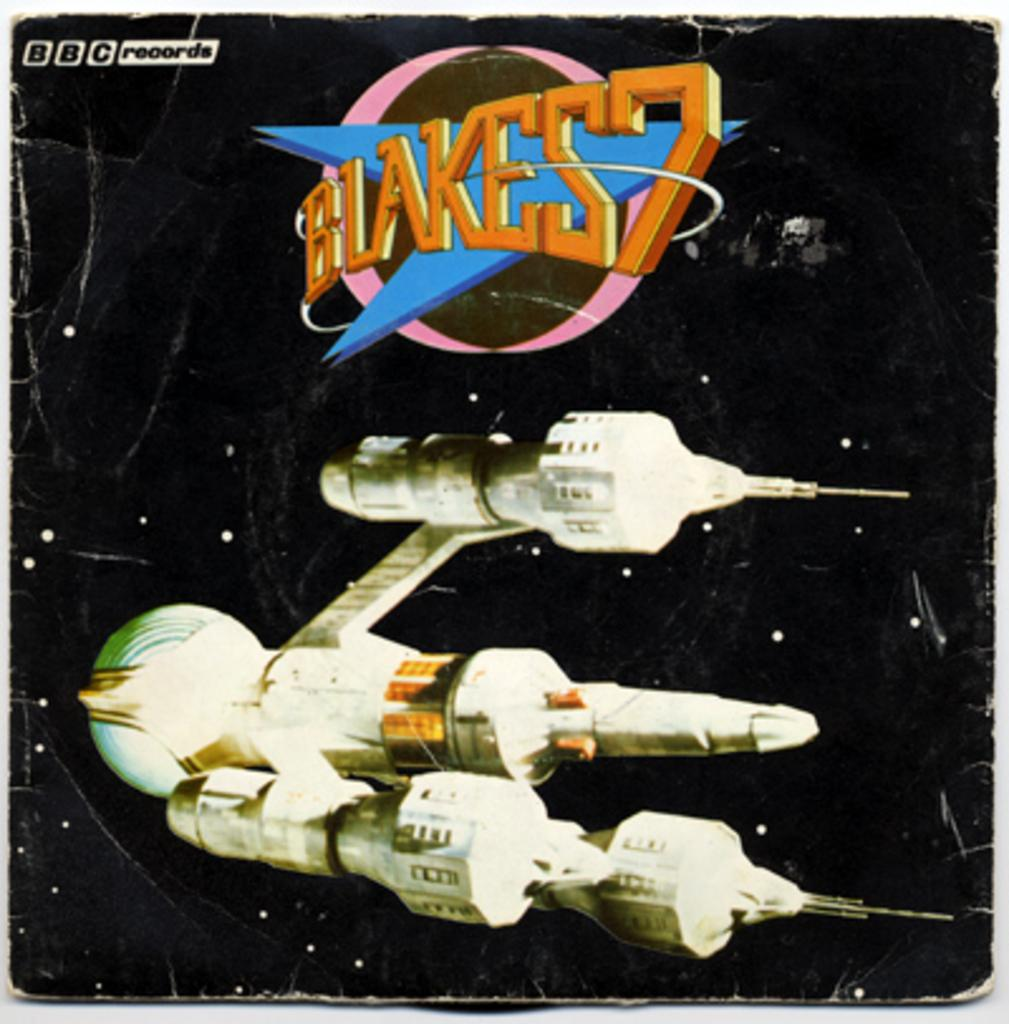What is depicted on the poster in the image? The poster features a spaceship. What else can be seen on the poster besides the spaceship? There is text on the poster. How many servants are shown attending to the spaceship on the poster? There are no servants present on the poster; it features a spaceship and text. What type of insect can be seen crawling on the spaceship in the image? There are no insects present on the spaceship in the image; it only features a spaceship and text. 